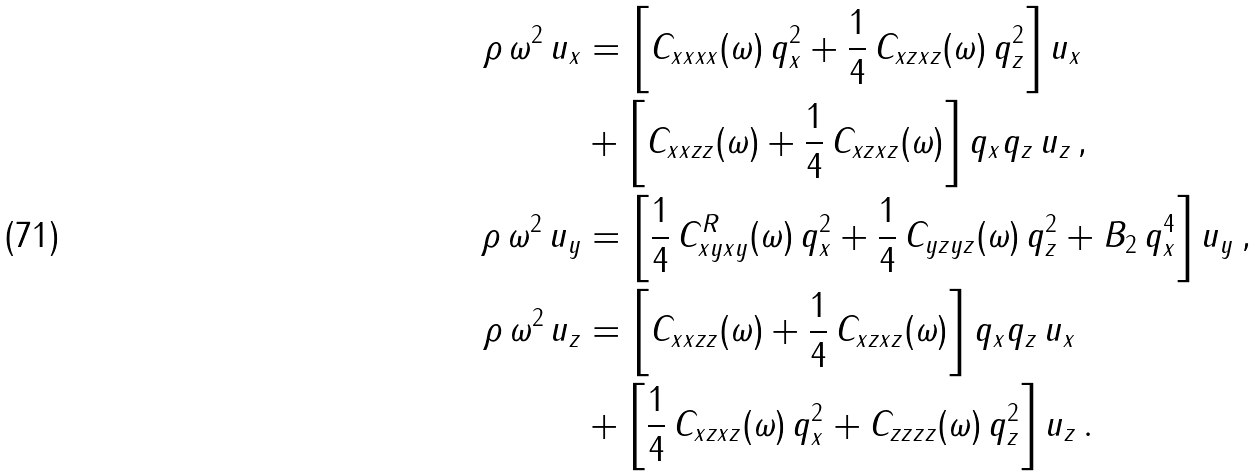Convert formula to latex. <formula><loc_0><loc_0><loc_500><loc_500>\rho \, \omega ^ { 2 } \, u _ { x } & = \left [ C _ { x x x x } ( \omega ) \, q _ { x } ^ { 2 } + \frac { 1 } { 4 } \, C _ { x z x z } ( \omega ) \, q _ { z } ^ { 2 } \right ] u _ { x } \\ & + \left [ C _ { x x z z } ( \omega ) + \frac { 1 } { 4 } \, C _ { x z x z } ( \omega ) \right ] q _ { x } q _ { z } \, u _ { z } \, , \\ \rho \, \omega ^ { 2 } \, u _ { y } & = \left [ \frac { 1 } { 4 } \, C _ { x y x y } ^ { R } ( \omega ) \, q _ { x } ^ { 2 } + \frac { 1 } { 4 } \, C _ { y z y z } ( \omega ) \, q _ { z } ^ { 2 } + B _ { 2 } \, q _ { x } ^ { 4 } \right ] u _ { y } \, , \\ \rho \, \omega ^ { 2 } \, u _ { z } & = \left [ C _ { x x z z } ( \omega ) + \frac { 1 } { 4 } \, C _ { x z x z } ( \omega ) \right ] q _ { x } q _ { z } \, u _ { x } \\ & + \left [ \frac { 1 } { 4 } \, C _ { x z x z } ( \omega ) \, q _ { x } ^ { 2 } + C _ { z z z z } ( \omega ) \, q _ { z } ^ { 2 } \right ] u _ { z } \, .</formula> 